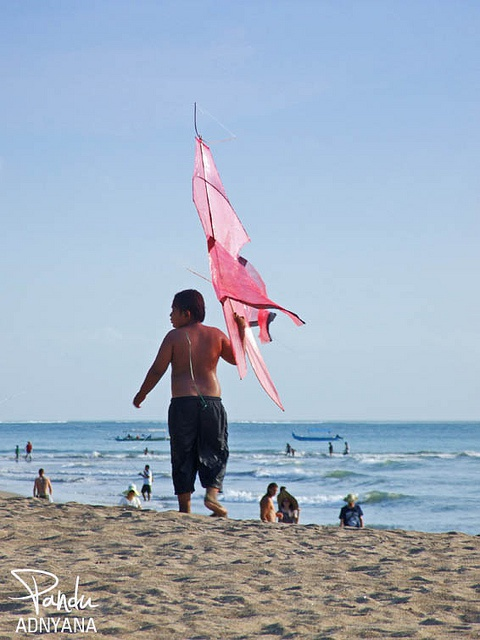Describe the objects in this image and their specific colors. I can see people in lightblue, black, maroon, gray, and brown tones, kite in lightblue, pink, lightpink, and salmon tones, people in lightblue, black, gray, navy, and blue tones, people in lightblue, black, maroon, brown, and darkgray tones, and people in lightblue, gray, maroon, black, and darkgray tones in this image. 